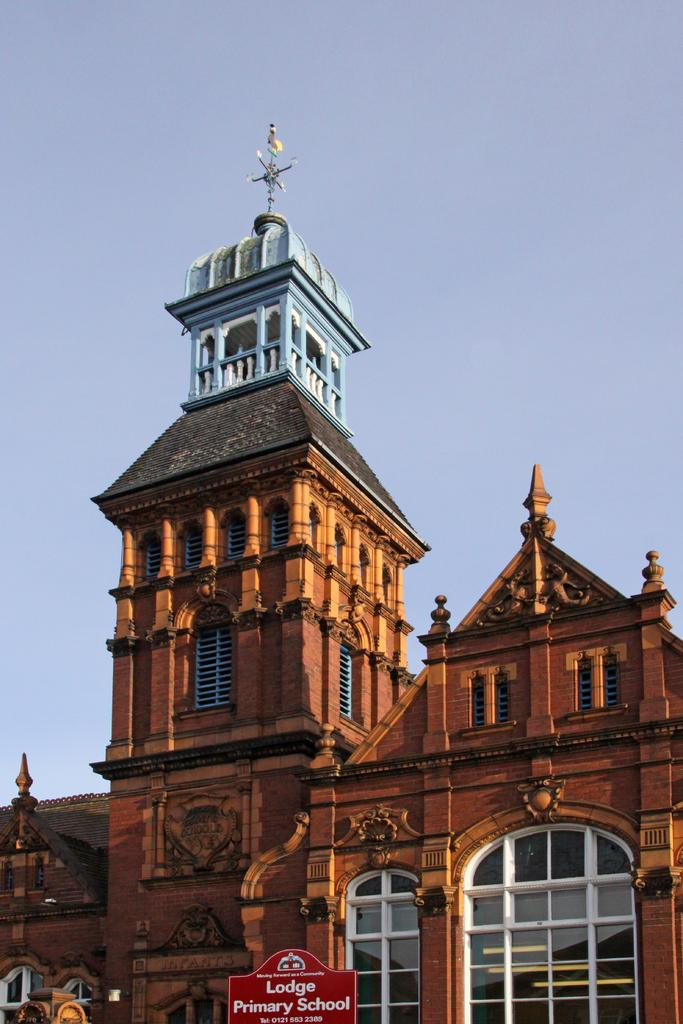What type of structure is in the picture? There is a building in the picture. What color is the building? The building is brown in color. What is located at the bottom of the picture? There is a board with text at the bottom of the picture. What is visible at the top of the picture? The sky is visible at the top of the picture. How many holes can be seen in the building in the image? There are no holes visible in the building in the image. What type of insurance is being advertised on the board at the bottom of the picture? There is no information about insurance on the board at the bottom of the picture; it only contains text. 